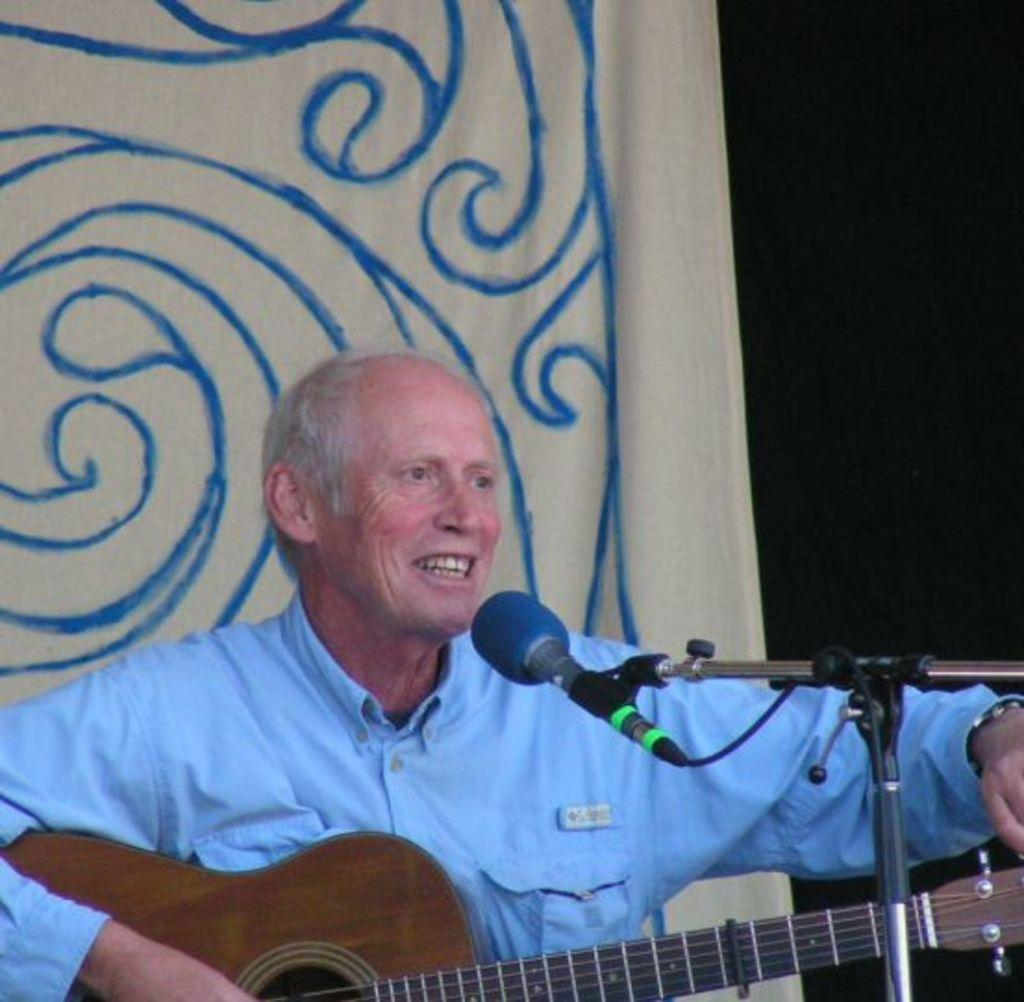What is the person in the image doing? The person is playing a guitar and singing. What object is the person using to amplify their voice? There is a microphone in the image. How is the microphone positioned in the image? There is a mic holder in the image. What type of quill is the person using to write lyrics in the image? There is no quill present in the image; the person is playing a guitar and singing. Can you see any flying machines in the image? There are no flying machines present in the image. 